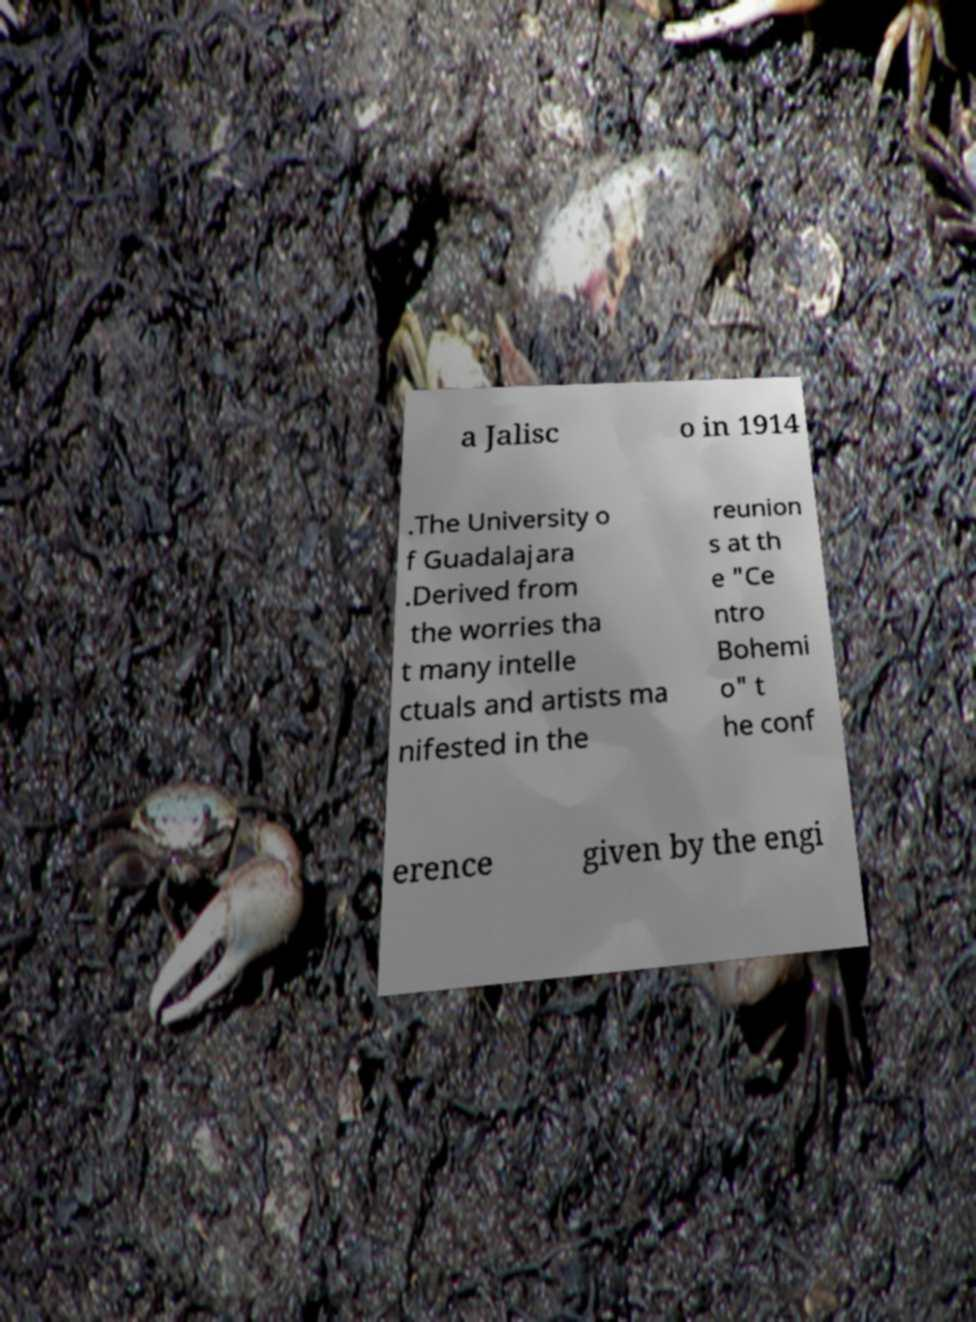For documentation purposes, I need the text within this image transcribed. Could you provide that? a Jalisc o in 1914 .The University o f Guadalajara .Derived from the worries tha t many intelle ctuals and artists ma nifested in the reunion s at th e "Ce ntro Bohemi o" t he conf erence given by the engi 